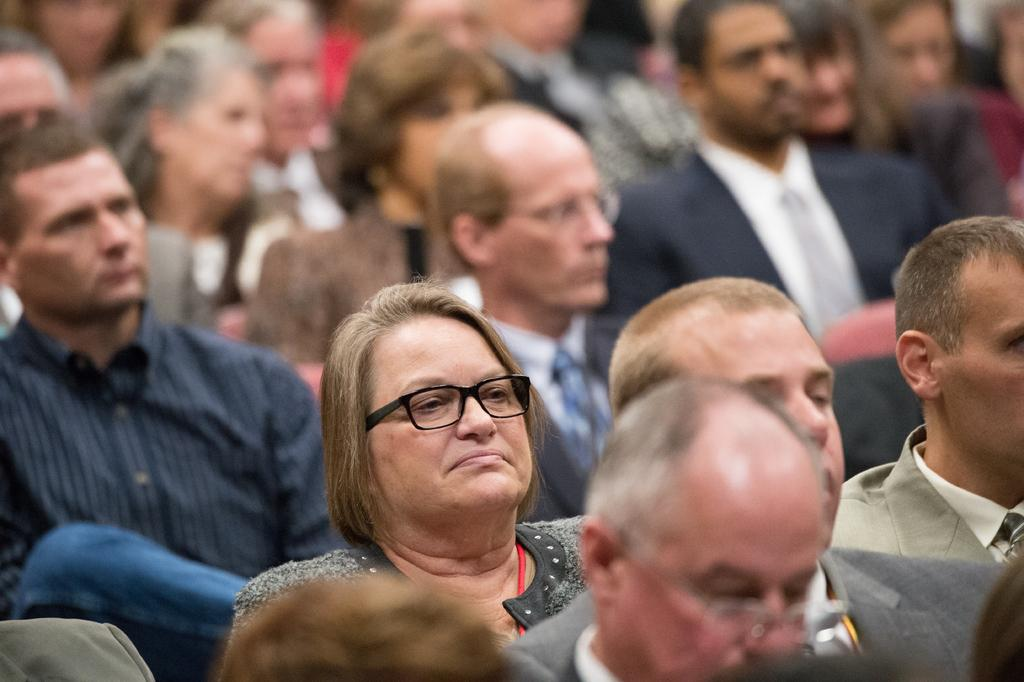What is the main subject of the image? The main subject of the image is a group of people. Can you describe the appearance of the people in the image? The people in the image are wearing different color dresses. Are there any specific accessories or items that can be seen on any of the people? Yes, one person in the group is wearing glasses (specs). What type of learning is taking place in the image? There is no indication of any learning activity taking place in the image. Can you see any ghosts in the image? There are no ghosts present in the image. 